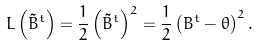Convert formula to latex. <formula><loc_0><loc_0><loc_500><loc_500>L \left ( \tilde { B } ^ { t } \right ) = \frac { 1 } { 2 } \left ( \tilde { B } ^ { t } \right ) ^ { 2 } = \frac { 1 } { 2 } \left ( B ^ { t } - \theta \right ) ^ { 2 } .</formula> 